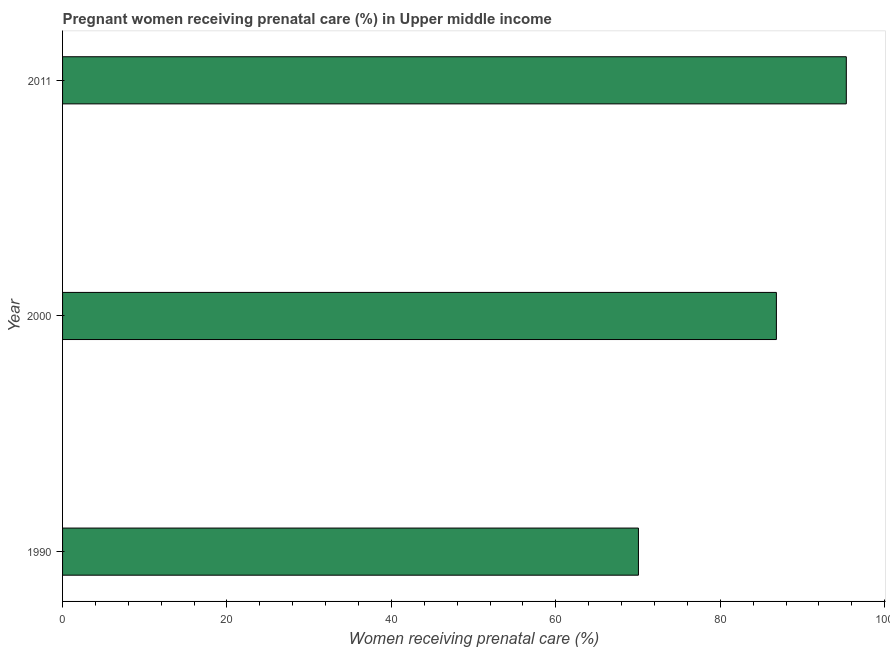What is the title of the graph?
Offer a very short reply. Pregnant women receiving prenatal care (%) in Upper middle income. What is the label or title of the X-axis?
Your answer should be compact. Women receiving prenatal care (%). What is the percentage of pregnant women receiving prenatal care in 2011?
Give a very brief answer. 95.33. Across all years, what is the maximum percentage of pregnant women receiving prenatal care?
Your answer should be very brief. 95.33. Across all years, what is the minimum percentage of pregnant women receiving prenatal care?
Your answer should be very brief. 70.05. In which year was the percentage of pregnant women receiving prenatal care maximum?
Make the answer very short. 2011. What is the sum of the percentage of pregnant women receiving prenatal care?
Make the answer very short. 252.21. What is the difference between the percentage of pregnant women receiving prenatal care in 2000 and 2011?
Give a very brief answer. -8.51. What is the average percentage of pregnant women receiving prenatal care per year?
Make the answer very short. 84.07. What is the median percentage of pregnant women receiving prenatal care?
Ensure brevity in your answer.  86.83. In how many years, is the percentage of pregnant women receiving prenatal care greater than 88 %?
Provide a short and direct response. 1. Do a majority of the years between 2000 and 2011 (inclusive) have percentage of pregnant women receiving prenatal care greater than 96 %?
Make the answer very short. No. What is the ratio of the percentage of pregnant women receiving prenatal care in 1990 to that in 2000?
Give a very brief answer. 0.81. Is the percentage of pregnant women receiving prenatal care in 2000 less than that in 2011?
Offer a very short reply. Yes. Is the difference between the percentage of pregnant women receiving prenatal care in 2000 and 2011 greater than the difference between any two years?
Give a very brief answer. No. What is the difference between the highest and the second highest percentage of pregnant women receiving prenatal care?
Keep it short and to the point. 8.51. Is the sum of the percentage of pregnant women receiving prenatal care in 2000 and 2011 greater than the maximum percentage of pregnant women receiving prenatal care across all years?
Make the answer very short. Yes. What is the difference between the highest and the lowest percentage of pregnant women receiving prenatal care?
Keep it short and to the point. 25.29. Are all the bars in the graph horizontal?
Your response must be concise. Yes. What is the difference between two consecutive major ticks on the X-axis?
Provide a short and direct response. 20. Are the values on the major ticks of X-axis written in scientific E-notation?
Your response must be concise. No. What is the Women receiving prenatal care (%) in 1990?
Offer a terse response. 70.05. What is the Women receiving prenatal care (%) in 2000?
Your response must be concise. 86.83. What is the Women receiving prenatal care (%) of 2011?
Ensure brevity in your answer.  95.33. What is the difference between the Women receiving prenatal care (%) in 1990 and 2000?
Give a very brief answer. -16.78. What is the difference between the Women receiving prenatal care (%) in 1990 and 2011?
Make the answer very short. -25.29. What is the difference between the Women receiving prenatal care (%) in 2000 and 2011?
Your answer should be very brief. -8.5. What is the ratio of the Women receiving prenatal care (%) in 1990 to that in 2000?
Offer a terse response. 0.81. What is the ratio of the Women receiving prenatal care (%) in 1990 to that in 2011?
Your response must be concise. 0.73. What is the ratio of the Women receiving prenatal care (%) in 2000 to that in 2011?
Offer a very short reply. 0.91. 